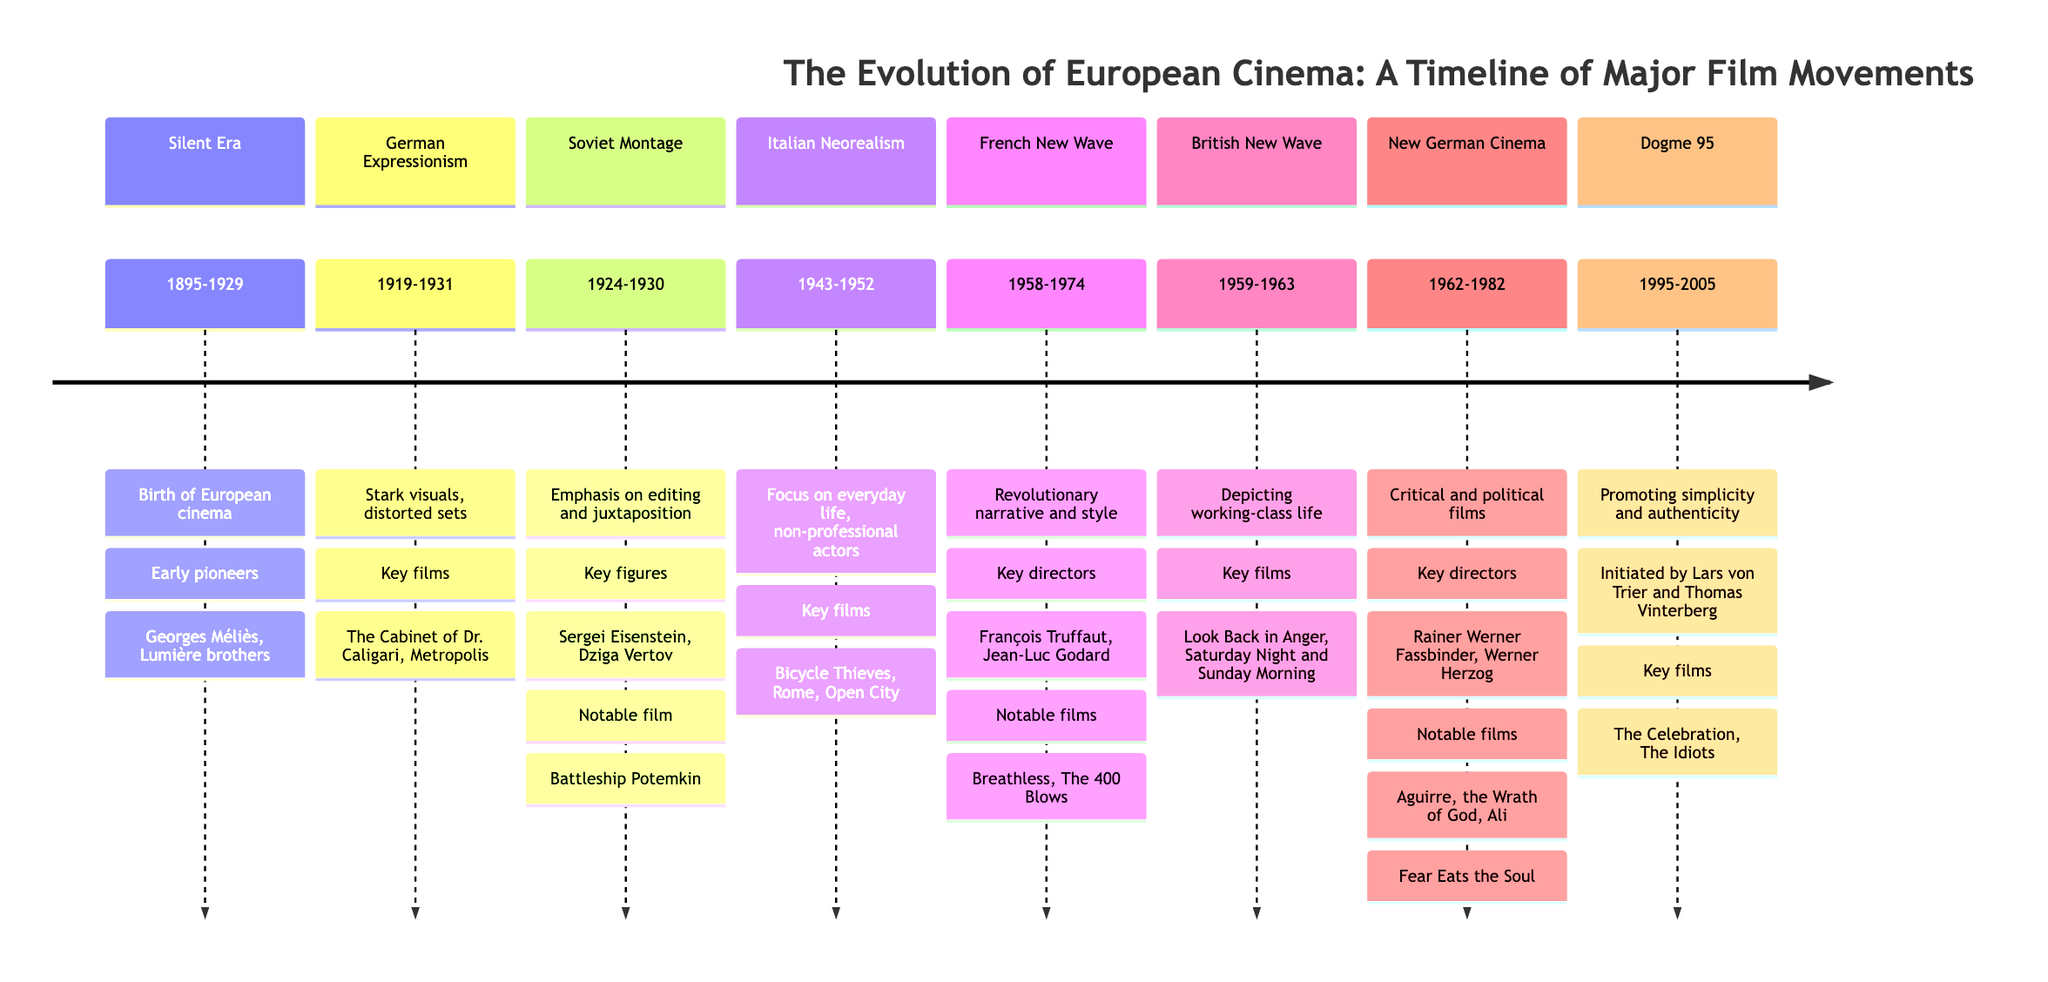What is the time span for the Silent Era? The Silent Era spans from 1895 to 1929, as indicated in the timeline section labeled "Silent Era."
Answer: 1895-1929 Which film movement emphasizes editing and juxtaposition? In the section "Soviet Montage," it specifically states that this movement emphasizes editing and juxtaposition.
Answer: Soviet Montage Who are two key figures in German Expressionism? The timeline lists key films associated with German Expressionism, and the question is answered by identifying which prominent figures are mentioned in that section. They are noted explicitly in the text.
Answer: The Cabinet of Dr. Caligari, Metropolis What type of actors were commonly used in Italian Neorealism? The Italian Neorealism section emphasizes the use of non-professional actors, which is a defining characteristic of this movement.
Answer: Non-professional actors In which years did Dogme 95 take place? The Dogme 95 section shows the specific years during which the movement was prominent, ranging from 1995 to 2005.
Answer: 1995-2005 What are two notable films from the French New Wave? By examining the section titled "French New Wave," we find two films specifically mentioned as notable: "Breathless" and "The 400 Blows."
Answer: Breathless, The 400 Blows Which film movement is characterized by critical and political films? The movement identified with this characteristic is the "New German Cinema" as stated in its section, highlighting its focus on critical and political themes in cinema.
Answer: New German Cinema How many film movements are listed in the diagram? Count the sections mentioned in the diagram: Silent Era, German Expressionism, Soviet Montage, Italian Neorealism, French New Wave, British New Wave, New German Cinema, and Dogme 95. There are eight listed movements in total.
Answer: 8 